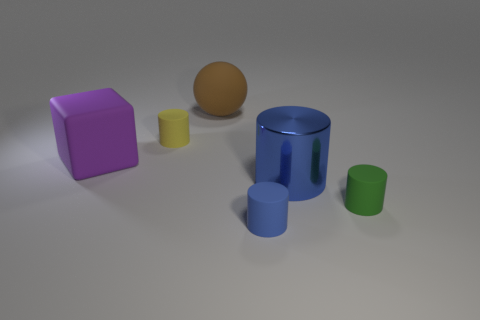Subtract all red spheres. How many blue cylinders are left? 2 Subtract all yellow cylinders. How many cylinders are left? 3 Subtract 1 cylinders. How many cylinders are left? 3 Subtract all big cylinders. How many cylinders are left? 3 Subtract all blocks. How many objects are left? 5 Add 2 blue metal cylinders. How many objects exist? 8 Subtract all red cylinders. Subtract all cyan cubes. How many cylinders are left? 4 Subtract all yellow shiny things. Subtract all small yellow rubber cylinders. How many objects are left? 5 Add 6 purple objects. How many purple objects are left? 7 Add 2 large blue cubes. How many large blue cubes exist? 2 